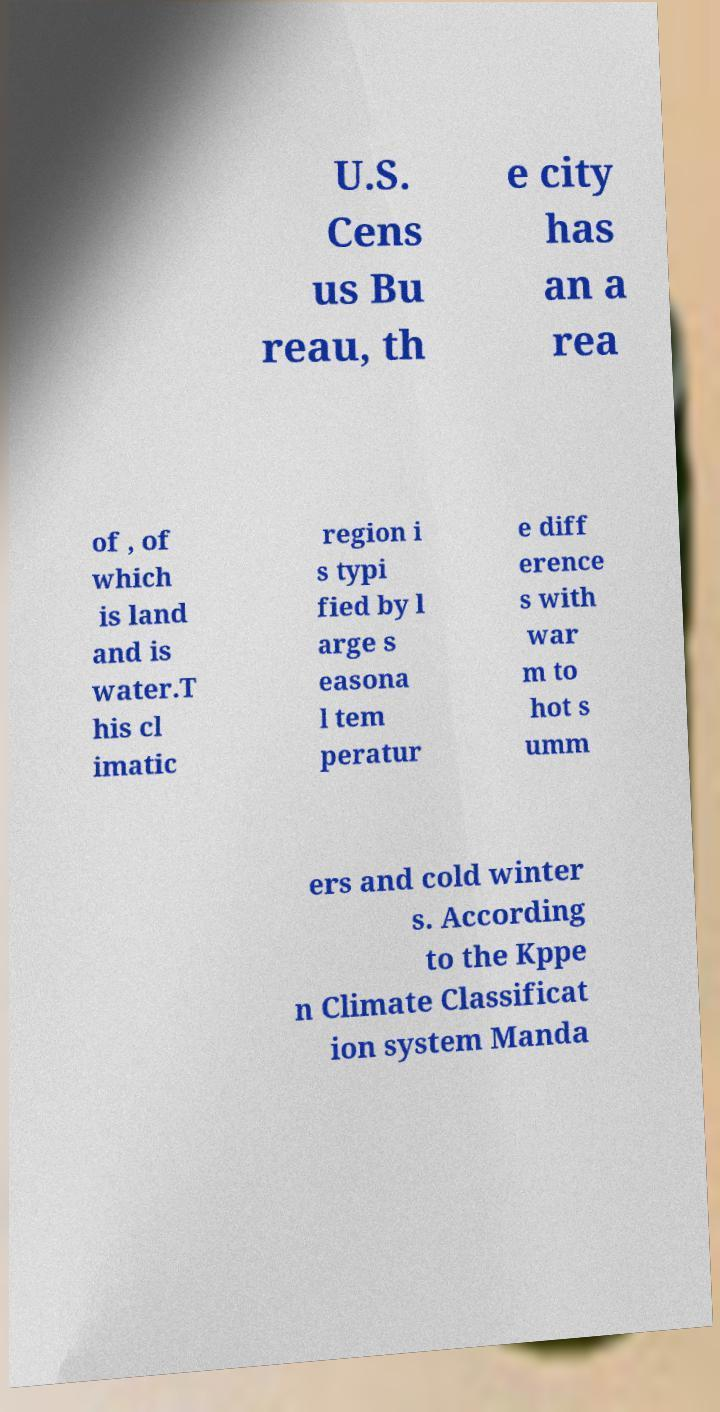Please identify and transcribe the text found in this image. U.S. Cens us Bu reau, th e city has an a rea of , of which is land and is water.T his cl imatic region i s typi fied by l arge s easona l tem peratur e diff erence s with war m to hot s umm ers and cold winter s. According to the Kppe n Climate Classificat ion system Manda 